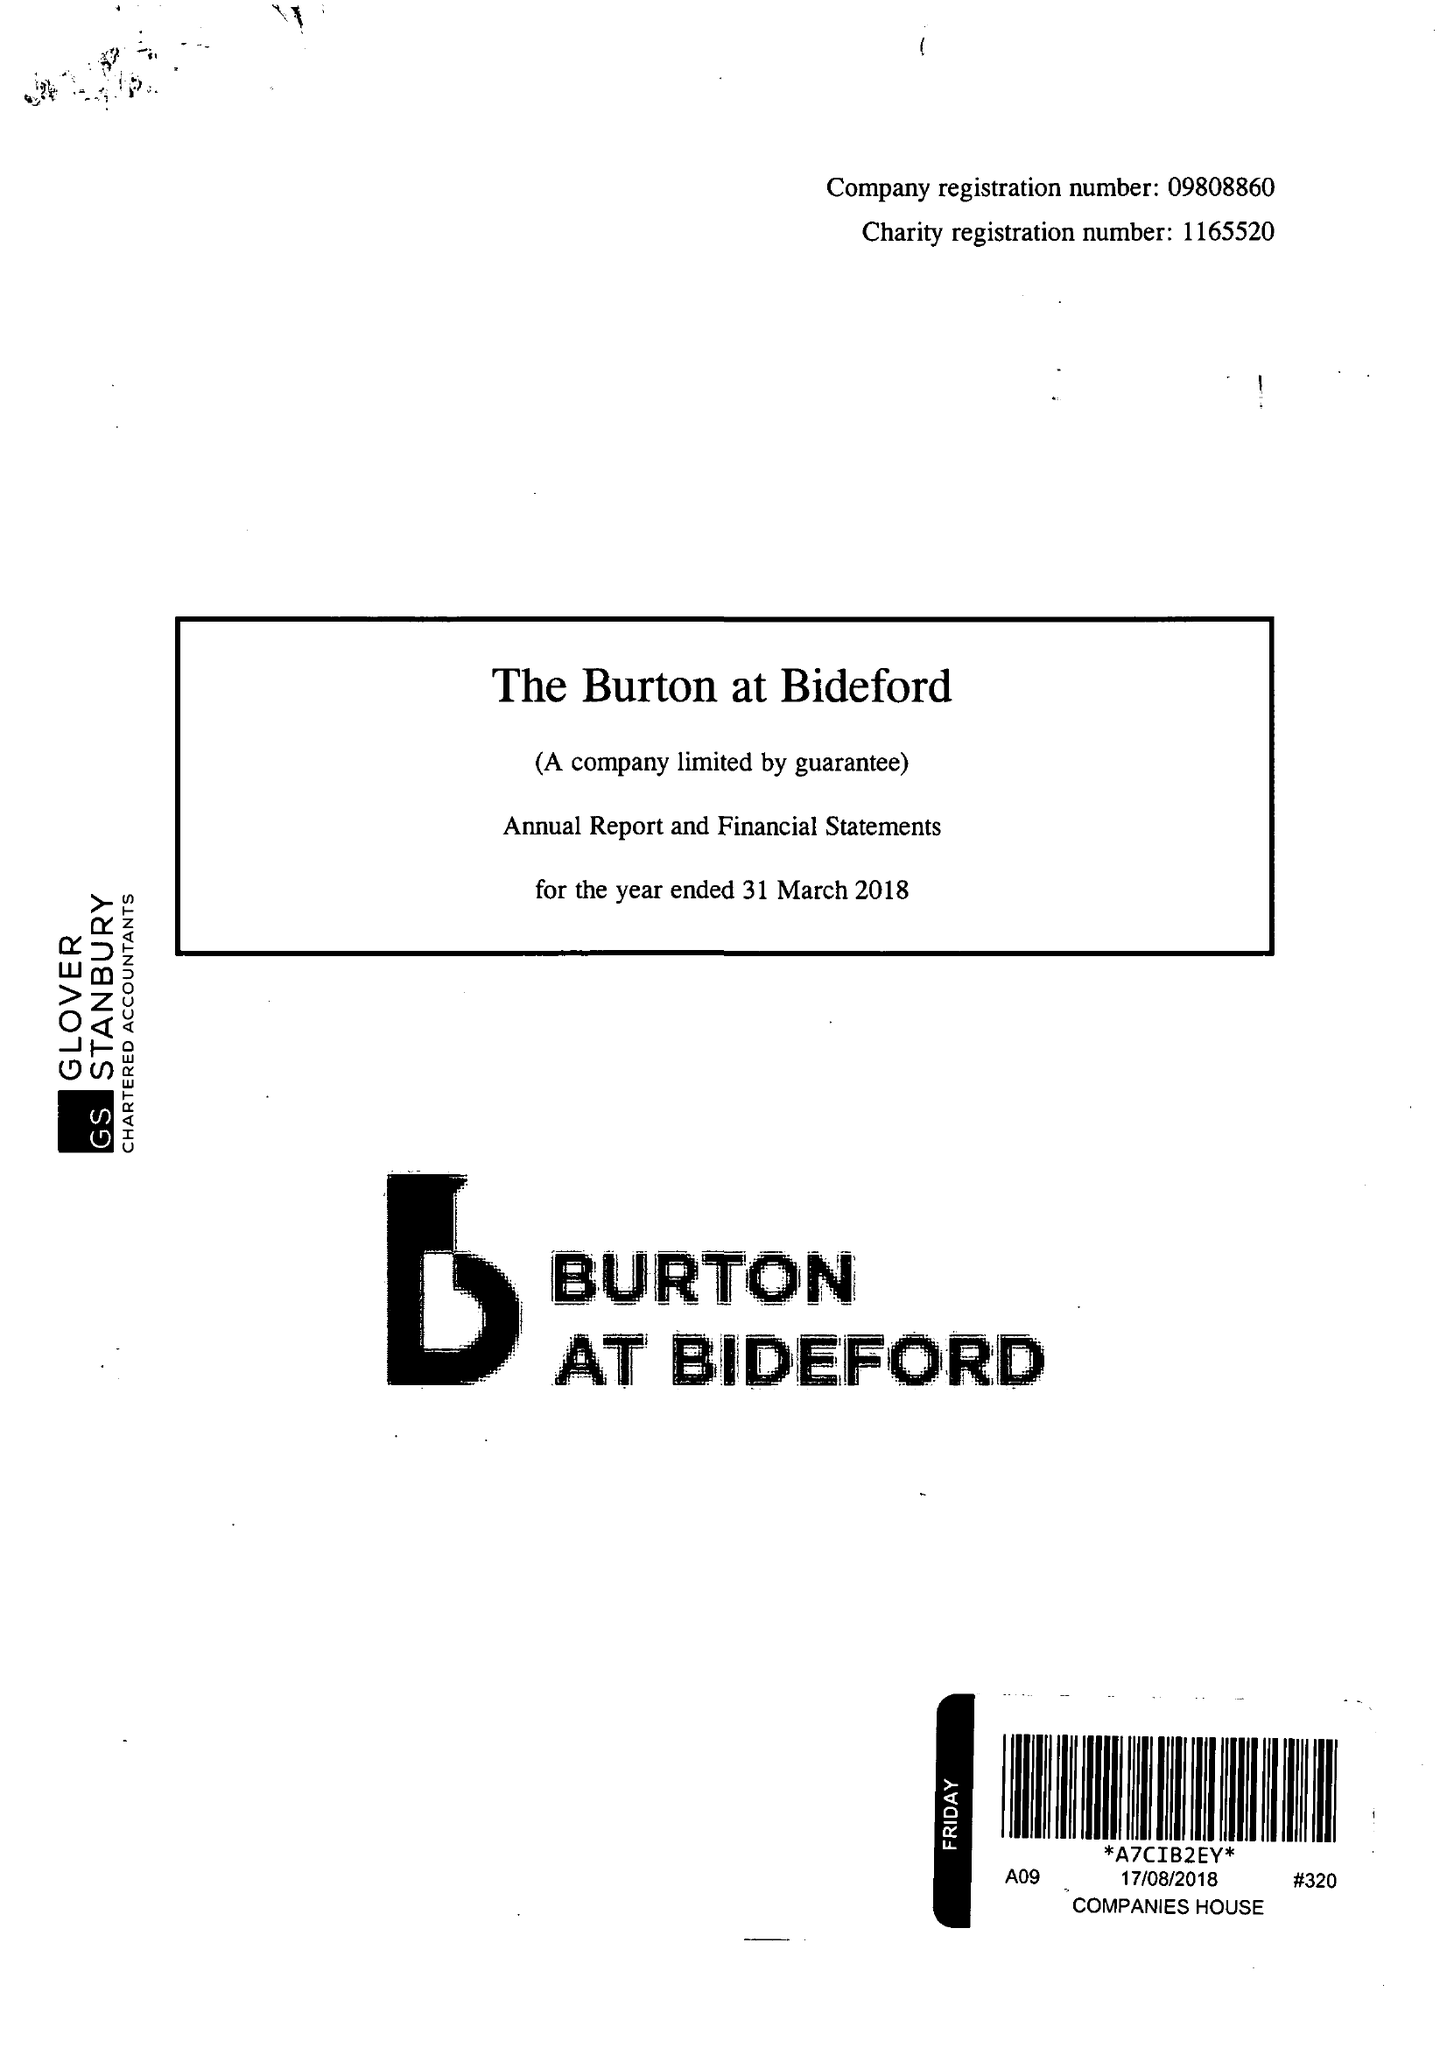What is the value for the address__street_line?
Answer the question using a single word or phrase. KINGSLEY ROAD 